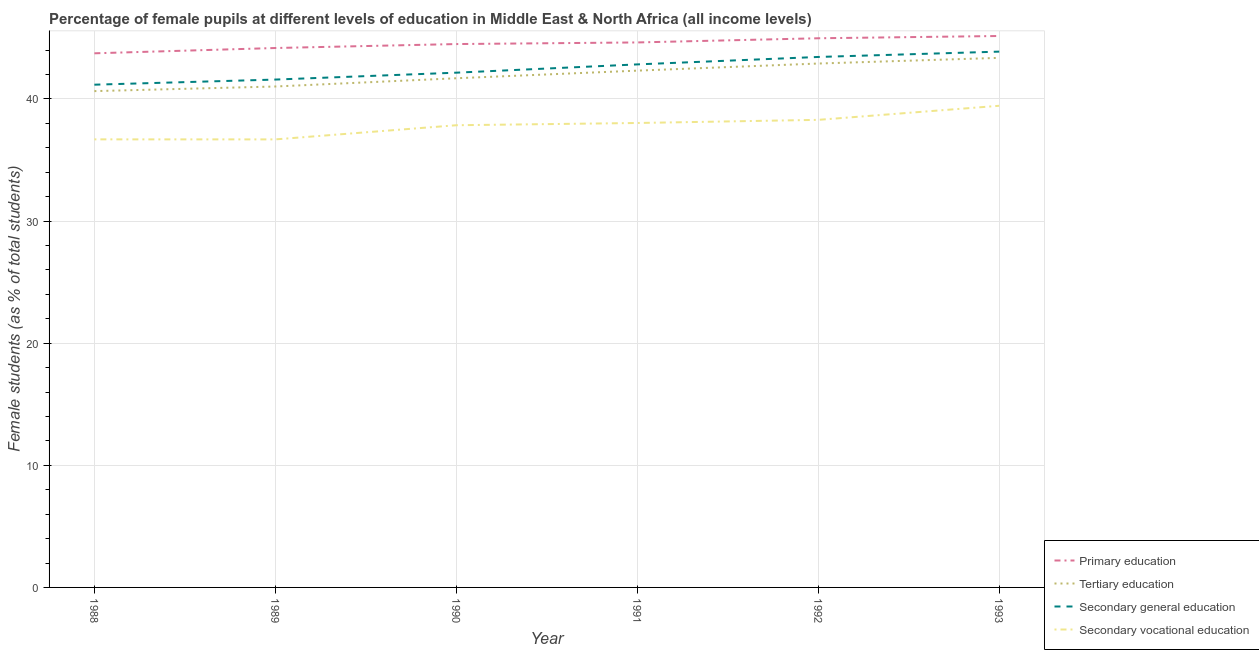What is the percentage of female students in secondary vocational education in 1992?
Offer a very short reply. 38.29. Across all years, what is the maximum percentage of female students in primary education?
Your answer should be compact. 45.16. Across all years, what is the minimum percentage of female students in tertiary education?
Offer a very short reply. 40.65. What is the total percentage of female students in secondary vocational education in the graph?
Keep it short and to the point. 227.01. What is the difference between the percentage of female students in tertiary education in 1992 and that in 1993?
Provide a short and direct response. -0.46. What is the difference between the percentage of female students in secondary education in 1989 and the percentage of female students in tertiary education in 1991?
Your answer should be compact. -0.73. What is the average percentage of female students in primary education per year?
Provide a succinct answer. 44.53. In the year 1988, what is the difference between the percentage of female students in tertiary education and percentage of female students in secondary vocational education?
Make the answer very short. 3.95. What is the ratio of the percentage of female students in primary education in 1991 to that in 1992?
Provide a succinct answer. 0.99. Is the percentage of female students in tertiary education in 1992 less than that in 1993?
Your answer should be very brief. Yes. What is the difference between the highest and the second highest percentage of female students in primary education?
Your answer should be very brief. 0.19. What is the difference between the highest and the lowest percentage of female students in tertiary education?
Offer a terse response. 2.72. In how many years, is the percentage of female students in secondary education greater than the average percentage of female students in secondary education taken over all years?
Your response must be concise. 3. Is the sum of the percentage of female students in secondary vocational education in 1990 and 1992 greater than the maximum percentage of female students in tertiary education across all years?
Provide a succinct answer. Yes. Is it the case that in every year, the sum of the percentage of female students in primary education and percentage of female students in tertiary education is greater than the percentage of female students in secondary education?
Your response must be concise. Yes. How many years are there in the graph?
Your response must be concise. 6. What is the difference between two consecutive major ticks on the Y-axis?
Give a very brief answer. 10. Does the graph contain any zero values?
Your answer should be very brief. No. Does the graph contain grids?
Offer a very short reply. Yes. What is the title of the graph?
Make the answer very short. Percentage of female pupils at different levels of education in Middle East & North Africa (all income levels). What is the label or title of the Y-axis?
Ensure brevity in your answer.  Female students (as % of total students). What is the Female students (as % of total students) in Primary education in 1988?
Provide a short and direct response. 43.74. What is the Female students (as % of total students) in Tertiary education in 1988?
Ensure brevity in your answer.  40.65. What is the Female students (as % of total students) of Secondary general education in 1988?
Your response must be concise. 41.17. What is the Female students (as % of total students) in Secondary vocational education in 1988?
Offer a terse response. 36.69. What is the Female students (as % of total students) in Primary education in 1989?
Offer a very short reply. 44.18. What is the Female students (as % of total students) of Tertiary education in 1989?
Offer a very short reply. 41.02. What is the Female students (as % of total students) in Secondary general education in 1989?
Your response must be concise. 41.59. What is the Female students (as % of total students) in Secondary vocational education in 1989?
Your response must be concise. 36.69. What is the Female students (as % of total students) of Primary education in 1990?
Give a very brief answer. 44.5. What is the Female students (as % of total students) in Tertiary education in 1990?
Keep it short and to the point. 41.7. What is the Female students (as % of total students) in Secondary general education in 1990?
Offer a very short reply. 42.16. What is the Female students (as % of total students) of Secondary vocational education in 1990?
Provide a short and direct response. 37.85. What is the Female students (as % of total students) in Primary education in 1991?
Keep it short and to the point. 44.63. What is the Female students (as % of total students) in Tertiary education in 1991?
Your answer should be very brief. 42.32. What is the Female students (as % of total students) in Secondary general education in 1991?
Your answer should be compact. 42.83. What is the Female students (as % of total students) in Secondary vocational education in 1991?
Make the answer very short. 38.03. What is the Female students (as % of total students) of Primary education in 1992?
Ensure brevity in your answer.  44.97. What is the Female students (as % of total students) of Tertiary education in 1992?
Ensure brevity in your answer.  42.9. What is the Female students (as % of total students) of Secondary general education in 1992?
Make the answer very short. 43.44. What is the Female students (as % of total students) of Secondary vocational education in 1992?
Ensure brevity in your answer.  38.29. What is the Female students (as % of total students) of Primary education in 1993?
Provide a short and direct response. 45.16. What is the Female students (as % of total students) of Tertiary education in 1993?
Ensure brevity in your answer.  43.37. What is the Female students (as % of total students) in Secondary general education in 1993?
Your answer should be very brief. 43.88. What is the Female students (as % of total students) in Secondary vocational education in 1993?
Your response must be concise. 39.45. Across all years, what is the maximum Female students (as % of total students) in Primary education?
Offer a very short reply. 45.16. Across all years, what is the maximum Female students (as % of total students) of Tertiary education?
Provide a short and direct response. 43.37. Across all years, what is the maximum Female students (as % of total students) in Secondary general education?
Ensure brevity in your answer.  43.88. Across all years, what is the maximum Female students (as % of total students) of Secondary vocational education?
Your answer should be very brief. 39.45. Across all years, what is the minimum Female students (as % of total students) in Primary education?
Offer a terse response. 43.74. Across all years, what is the minimum Female students (as % of total students) of Tertiary education?
Make the answer very short. 40.65. Across all years, what is the minimum Female students (as % of total students) of Secondary general education?
Keep it short and to the point. 41.17. Across all years, what is the minimum Female students (as % of total students) of Secondary vocational education?
Your response must be concise. 36.69. What is the total Female students (as % of total students) in Primary education in the graph?
Your answer should be very brief. 267.18. What is the total Female students (as % of total students) in Tertiary education in the graph?
Offer a very short reply. 251.97. What is the total Female students (as % of total students) of Secondary general education in the graph?
Keep it short and to the point. 255.08. What is the total Female students (as % of total students) in Secondary vocational education in the graph?
Your answer should be compact. 227.01. What is the difference between the Female students (as % of total students) of Primary education in 1988 and that in 1989?
Keep it short and to the point. -0.43. What is the difference between the Female students (as % of total students) of Tertiary education in 1988 and that in 1989?
Make the answer very short. -0.38. What is the difference between the Female students (as % of total students) of Secondary general education in 1988 and that in 1989?
Provide a short and direct response. -0.42. What is the difference between the Female students (as % of total students) of Secondary vocational education in 1988 and that in 1989?
Provide a short and direct response. 0. What is the difference between the Female students (as % of total students) of Primary education in 1988 and that in 1990?
Your response must be concise. -0.76. What is the difference between the Female students (as % of total students) of Tertiary education in 1988 and that in 1990?
Make the answer very short. -1.05. What is the difference between the Female students (as % of total students) in Secondary general education in 1988 and that in 1990?
Keep it short and to the point. -0.98. What is the difference between the Female students (as % of total students) in Secondary vocational education in 1988 and that in 1990?
Your response must be concise. -1.16. What is the difference between the Female students (as % of total students) of Primary education in 1988 and that in 1991?
Give a very brief answer. -0.89. What is the difference between the Female students (as % of total students) of Tertiary education in 1988 and that in 1991?
Make the answer very short. -1.68. What is the difference between the Female students (as % of total students) of Secondary general education in 1988 and that in 1991?
Offer a terse response. -1.66. What is the difference between the Female students (as % of total students) of Secondary vocational education in 1988 and that in 1991?
Provide a succinct answer. -1.34. What is the difference between the Female students (as % of total students) of Primary education in 1988 and that in 1992?
Make the answer very short. -1.23. What is the difference between the Female students (as % of total students) of Tertiary education in 1988 and that in 1992?
Offer a terse response. -2.26. What is the difference between the Female students (as % of total students) in Secondary general education in 1988 and that in 1992?
Provide a short and direct response. -2.27. What is the difference between the Female students (as % of total students) in Secondary vocational education in 1988 and that in 1992?
Provide a short and direct response. -1.6. What is the difference between the Female students (as % of total students) in Primary education in 1988 and that in 1993?
Your answer should be compact. -1.42. What is the difference between the Female students (as % of total students) of Tertiary education in 1988 and that in 1993?
Your answer should be very brief. -2.72. What is the difference between the Female students (as % of total students) in Secondary general education in 1988 and that in 1993?
Your answer should be compact. -2.71. What is the difference between the Female students (as % of total students) in Secondary vocational education in 1988 and that in 1993?
Offer a very short reply. -2.75. What is the difference between the Female students (as % of total students) of Primary education in 1989 and that in 1990?
Keep it short and to the point. -0.32. What is the difference between the Female students (as % of total students) in Tertiary education in 1989 and that in 1990?
Make the answer very short. -0.67. What is the difference between the Female students (as % of total students) in Secondary general education in 1989 and that in 1990?
Give a very brief answer. -0.56. What is the difference between the Female students (as % of total students) of Secondary vocational education in 1989 and that in 1990?
Your answer should be compact. -1.16. What is the difference between the Female students (as % of total students) of Primary education in 1989 and that in 1991?
Make the answer very short. -0.46. What is the difference between the Female students (as % of total students) of Tertiary education in 1989 and that in 1991?
Provide a short and direct response. -1.3. What is the difference between the Female students (as % of total students) in Secondary general education in 1989 and that in 1991?
Offer a very short reply. -1.24. What is the difference between the Female students (as % of total students) in Secondary vocational education in 1989 and that in 1991?
Give a very brief answer. -1.34. What is the difference between the Female students (as % of total students) in Primary education in 1989 and that in 1992?
Your response must be concise. -0.8. What is the difference between the Female students (as % of total students) of Tertiary education in 1989 and that in 1992?
Offer a terse response. -1.88. What is the difference between the Female students (as % of total students) in Secondary general education in 1989 and that in 1992?
Ensure brevity in your answer.  -1.85. What is the difference between the Female students (as % of total students) of Secondary vocational education in 1989 and that in 1992?
Make the answer very short. -1.6. What is the difference between the Female students (as % of total students) in Primary education in 1989 and that in 1993?
Offer a terse response. -0.98. What is the difference between the Female students (as % of total students) of Tertiary education in 1989 and that in 1993?
Keep it short and to the point. -2.35. What is the difference between the Female students (as % of total students) in Secondary general education in 1989 and that in 1993?
Your response must be concise. -2.29. What is the difference between the Female students (as % of total students) in Secondary vocational education in 1989 and that in 1993?
Ensure brevity in your answer.  -2.75. What is the difference between the Female students (as % of total students) of Primary education in 1990 and that in 1991?
Keep it short and to the point. -0.13. What is the difference between the Female students (as % of total students) in Tertiary education in 1990 and that in 1991?
Offer a very short reply. -0.62. What is the difference between the Female students (as % of total students) of Secondary general education in 1990 and that in 1991?
Give a very brief answer. -0.68. What is the difference between the Female students (as % of total students) of Secondary vocational education in 1990 and that in 1991?
Offer a very short reply. -0.18. What is the difference between the Female students (as % of total students) of Primary education in 1990 and that in 1992?
Offer a very short reply. -0.47. What is the difference between the Female students (as % of total students) of Tertiary education in 1990 and that in 1992?
Your answer should be very brief. -1.21. What is the difference between the Female students (as % of total students) in Secondary general education in 1990 and that in 1992?
Your response must be concise. -1.29. What is the difference between the Female students (as % of total students) in Secondary vocational education in 1990 and that in 1992?
Your answer should be compact. -0.44. What is the difference between the Female students (as % of total students) in Primary education in 1990 and that in 1993?
Offer a very short reply. -0.66. What is the difference between the Female students (as % of total students) of Tertiary education in 1990 and that in 1993?
Provide a short and direct response. -1.67. What is the difference between the Female students (as % of total students) of Secondary general education in 1990 and that in 1993?
Give a very brief answer. -1.72. What is the difference between the Female students (as % of total students) of Secondary vocational education in 1990 and that in 1993?
Your answer should be very brief. -1.59. What is the difference between the Female students (as % of total students) of Primary education in 1991 and that in 1992?
Your answer should be compact. -0.34. What is the difference between the Female students (as % of total students) in Tertiary education in 1991 and that in 1992?
Provide a succinct answer. -0.58. What is the difference between the Female students (as % of total students) of Secondary general education in 1991 and that in 1992?
Offer a terse response. -0.61. What is the difference between the Female students (as % of total students) of Secondary vocational education in 1991 and that in 1992?
Your answer should be compact. -0.26. What is the difference between the Female students (as % of total students) in Primary education in 1991 and that in 1993?
Your response must be concise. -0.53. What is the difference between the Female students (as % of total students) of Tertiary education in 1991 and that in 1993?
Give a very brief answer. -1.05. What is the difference between the Female students (as % of total students) in Secondary general education in 1991 and that in 1993?
Provide a succinct answer. -1.05. What is the difference between the Female students (as % of total students) of Secondary vocational education in 1991 and that in 1993?
Keep it short and to the point. -1.41. What is the difference between the Female students (as % of total students) in Primary education in 1992 and that in 1993?
Your response must be concise. -0.19. What is the difference between the Female students (as % of total students) of Tertiary education in 1992 and that in 1993?
Your response must be concise. -0.46. What is the difference between the Female students (as % of total students) of Secondary general education in 1992 and that in 1993?
Offer a very short reply. -0.44. What is the difference between the Female students (as % of total students) in Secondary vocational education in 1992 and that in 1993?
Make the answer very short. -1.15. What is the difference between the Female students (as % of total students) of Primary education in 1988 and the Female students (as % of total students) of Tertiary education in 1989?
Offer a terse response. 2.72. What is the difference between the Female students (as % of total students) in Primary education in 1988 and the Female students (as % of total students) in Secondary general education in 1989?
Offer a very short reply. 2.15. What is the difference between the Female students (as % of total students) in Primary education in 1988 and the Female students (as % of total students) in Secondary vocational education in 1989?
Your answer should be very brief. 7.05. What is the difference between the Female students (as % of total students) in Tertiary education in 1988 and the Female students (as % of total students) in Secondary general education in 1989?
Make the answer very short. -0.95. What is the difference between the Female students (as % of total students) in Tertiary education in 1988 and the Female students (as % of total students) in Secondary vocational education in 1989?
Your response must be concise. 3.95. What is the difference between the Female students (as % of total students) of Secondary general education in 1988 and the Female students (as % of total students) of Secondary vocational education in 1989?
Provide a short and direct response. 4.48. What is the difference between the Female students (as % of total students) in Primary education in 1988 and the Female students (as % of total students) in Tertiary education in 1990?
Keep it short and to the point. 2.04. What is the difference between the Female students (as % of total students) in Primary education in 1988 and the Female students (as % of total students) in Secondary general education in 1990?
Provide a short and direct response. 1.59. What is the difference between the Female students (as % of total students) of Primary education in 1988 and the Female students (as % of total students) of Secondary vocational education in 1990?
Provide a succinct answer. 5.89. What is the difference between the Female students (as % of total students) in Tertiary education in 1988 and the Female students (as % of total students) in Secondary general education in 1990?
Make the answer very short. -1.51. What is the difference between the Female students (as % of total students) in Tertiary education in 1988 and the Female students (as % of total students) in Secondary vocational education in 1990?
Make the answer very short. 2.79. What is the difference between the Female students (as % of total students) of Secondary general education in 1988 and the Female students (as % of total students) of Secondary vocational education in 1990?
Your response must be concise. 3.32. What is the difference between the Female students (as % of total students) of Primary education in 1988 and the Female students (as % of total students) of Tertiary education in 1991?
Offer a terse response. 1.42. What is the difference between the Female students (as % of total students) of Primary education in 1988 and the Female students (as % of total students) of Secondary general education in 1991?
Make the answer very short. 0.91. What is the difference between the Female students (as % of total students) in Primary education in 1988 and the Female students (as % of total students) in Secondary vocational education in 1991?
Ensure brevity in your answer.  5.71. What is the difference between the Female students (as % of total students) in Tertiary education in 1988 and the Female students (as % of total students) in Secondary general education in 1991?
Provide a short and direct response. -2.19. What is the difference between the Female students (as % of total students) of Tertiary education in 1988 and the Female students (as % of total students) of Secondary vocational education in 1991?
Your answer should be compact. 2.61. What is the difference between the Female students (as % of total students) of Secondary general education in 1988 and the Female students (as % of total students) of Secondary vocational education in 1991?
Give a very brief answer. 3.14. What is the difference between the Female students (as % of total students) of Primary education in 1988 and the Female students (as % of total students) of Tertiary education in 1992?
Your answer should be very brief. 0.84. What is the difference between the Female students (as % of total students) of Primary education in 1988 and the Female students (as % of total students) of Secondary general education in 1992?
Make the answer very short. 0.3. What is the difference between the Female students (as % of total students) of Primary education in 1988 and the Female students (as % of total students) of Secondary vocational education in 1992?
Your answer should be very brief. 5.45. What is the difference between the Female students (as % of total students) in Tertiary education in 1988 and the Female students (as % of total students) in Secondary general education in 1992?
Your response must be concise. -2.8. What is the difference between the Female students (as % of total students) of Tertiary education in 1988 and the Female students (as % of total students) of Secondary vocational education in 1992?
Your answer should be very brief. 2.35. What is the difference between the Female students (as % of total students) in Secondary general education in 1988 and the Female students (as % of total students) in Secondary vocational education in 1992?
Your response must be concise. 2.88. What is the difference between the Female students (as % of total students) of Primary education in 1988 and the Female students (as % of total students) of Tertiary education in 1993?
Give a very brief answer. 0.37. What is the difference between the Female students (as % of total students) of Primary education in 1988 and the Female students (as % of total students) of Secondary general education in 1993?
Provide a short and direct response. -0.14. What is the difference between the Female students (as % of total students) of Primary education in 1988 and the Female students (as % of total students) of Secondary vocational education in 1993?
Give a very brief answer. 4.3. What is the difference between the Female students (as % of total students) in Tertiary education in 1988 and the Female students (as % of total students) in Secondary general education in 1993?
Your response must be concise. -3.23. What is the difference between the Female students (as % of total students) of Tertiary education in 1988 and the Female students (as % of total students) of Secondary vocational education in 1993?
Offer a terse response. 1.2. What is the difference between the Female students (as % of total students) of Secondary general education in 1988 and the Female students (as % of total students) of Secondary vocational education in 1993?
Ensure brevity in your answer.  1.73. What is the difference between the Female students (as % of total students) in Primary education in 1989 and the Female students (as % of total students) in Tertiary education in 1990?
Your answer should be very brief. 2.48. What is the difference between the Female students (as % of total students) of Primary education in 1989 and the Female students (as % of total students) of Secondary general education in 1990?
Give a very brief answer. 2.02. What is the difference between the Female students (as % of total students) in Primary education in 1989 and the Female students (as % of total students) in Secondary vocational education in 1990?
Ensure brevity in your answer.  6.32. What is the difference between the Female students (as % of total students) in Tertiary education in 1989 and the Female students (as % of total students) in Secondary general education in 1990?
Provide a short and direct response. -1.13. What is the difference between the Female students (as % of total students) of Tertiary education in 1989 and the Female students (as % of total students) of Secondary vocational education in 1990?
Provide a succinct answer. 3.17. What is the difference between the Female students (as % of total students) in Secondary general education in 1989 and the Female students (as % of total students) in Secondary vocational education in 1990?
Your answer should be compact. 3.74. What is the difference between the Female students (as % of total students) of Primary education in 1989 and the Female students (as % of total students) of Tertiary education in 1991?
Provide a short and direct response. 1.85. What is the difference between the Female students (as % of total students) in Primary education in 1989 and the Female students (as % of total students) in Secondary general education in 1991?
Your response must be concise. 1.34. What is the difference between the Female students (as % of total students) in Primary education in 1989 and the Female students (as % of total students) in Secondary vocational education in 1991?
Ensure brevity in your answer.  6.14. What is the difference between the Female students (as % of total students) in Tertiary education in 1989 and the Female students (as % of total students) in Secondary general education in 1991?
Your response must be concise. -1.81. What is the difference between the Female students (as % of total students) of Tertiary education in 1989 and the Female students (as % of total students) of Secondary vocational education in 1991?
Keep it short and to the point. 2.99. What is the difference between the Female students (as % of total students) in Secondary general education in 1989 and the Female students (as % of total students) in Secondary vocational education in 1991?
Offer a terse response. 3.56. What is the difference between the Female students (as % of total students) of Primary education in 1989 and the Female students (as % of total students) of Tertiary education in 1992?
Your answer should be very brief. 1.27. What is the difference between the Female students (as % of total students) in Primary education in 1989 and the Female students (as % of total students) in Secondary general education in 1992?
Give a very brief answer. 0.73. What is the difference between the Female students (as % of total students) in Primary education in 1989 and the Female students (as % of total students) in Secondary vocational education in 1992?
Provide a succinct answer. 5.88. What is the difference between the Female students (as % of total students) of Tertiary education in 1989 and the Female students (as % of total students) of Secondary general education in 1992?
Keep it short and to the point. -2.42. What is the difference between the Female students (as % of total students) of Tertiary education in 1989 and the Female students (as % of total students) of Secondary vocational education in 1992?
Your response must be concise. 2.73. What is the difference between the Female students (as % of total students) of Secondary general education in 1989 and the Female students (as % of total students) of Secondary vocational education in 1992?
Your answer should be compact. 3.3. What is the difference between the Female students (as % of total students) in Primary education in 1989 and the Female students (as % of total students) in Tertiary education in 1993?
Provide a succinct answer. 0.81. What is the difference between the Female students (as % of total students) in Primary education in 1989 and the Female students (as % of total students) in Secondary general education in 1993?
Your answer should be very brief. 0.3. What is the difference between the Female students (as % of total students) in Primary education in 1989 and the Female students (as % of total students) in Secondary vocational education in 1993?
Ensure brevity in your answer.  4.73. What is the difference between the Female students (as % of total students) in Tertiary education in 1989 and the Female students (as % of total students) in Secondary general education in 1993?
Make the answer very short. -2.86. What is the difference between the Female students (as % of total students) of Tertiary education in 1989 and the Female students (as % of total students) of Secondary vocational education in 1993?
Your response must be concise. 1.58. What is the difference between the Female students (as % of total students) in Secondary general education in 1989 and the Female students (as % of total students) in Secondary vocational education in 1993?
Your answer should be very brief. 2.15. What is the difference between the Female students (as % of total students) in Primary education in 1990 and the Female students (as % of total students) in Tertiary education in 1991?
Give a very brief answer. 2.18. What is the difference between the Female students (as % of total students) of Primary education in 1990 and the Female students (as % of total students) of Secondary general education in 1991?
Give a very brief answer. 1.67. What is the difference between the Female students (as % of total students) of Primary education in 1990 and the Female students (as % of total students) of Secondary vocational education in 1991?
Offer a terse response. 6.46. What is the difference between the Female students (as % of total students) in Tertiary education in 1990 and the Female students (as % of total students) in Secondary general education in 1991?
Offer a terse response. -1.13. What is the difference between the Female students (as % of total students) of Tertiary education in 1990 and the Female students (as % of total students) of Secondary vocational education in 1991?
Ensure brevity in your answer.  3.66. What is the difference between the Female students (as % of total students) in Secondary general education in 1990 and the Female students (as % of total students) in Secondary vocational education in 1991?
Your answer should be very brief. 4.12. What is the difference between the Female students (as % of total students) in Primary education in 1990 and the Female students (as % of total students) in Tertiary education in 1992?
Keep it short and to the point. 1.59. What is the difference between the Female students (as % of total students) of Primary education in 1990 and the Female students (as % of total students) of Secondary general education in 1992?
Your response must be concise. 1.06. What is the difference between the Female students (as % of total students) in Primary education in 1990 and the Female students (as % of total students) in Secondary vocational education in 1992?
Provide a short and direct response. 6.21. What is the difference between the Female students (as % of total students) in Tertiary education in 1990 and the Female students (as % of total students) in Secondary general education in 1992?
Offer a very short reply. -1.74. What is the difference between the Female students (as % of total students) of Tertiary education in 1990 and the Female students (as % of total students) of Secondary vocational education in 1992?
Give a very brief answer. 3.41. What is the difference between the Female students (as % of total students) in Secondary general education in 1990 and the Female students (as % of total students) in Secondary vocational education in 1992?
Give a very brief answer. 3.86. What is the difference between the Female students (as % of total students) of Primary education in 1990 and the Female students (as % of total students) of Tertiary education in 1993?
Your answer should be very brief. 1.13. What is the difference between the Female students (as % of total students) in Primary education in 1990 and the Female students (as % of total students) in Secondary general education in 1993?
Keep it short and to the point. 0.62. What is the difference between the Female students (as % of total students) in Primary education in 1990 and the Female students (as % of total students) in Secondary vocational education in 1993?
Offer a terse response. 5.05. What is the difference between the Female students (as % of total students) in Tertiary education in 1990 and the Female students (as % of total students) in Secondary general education in 1993?
Provide a succinct answer. -2.18. What is the difference between the Female students (as % of total students) in Tertiary education in 1990 and the Female students (as % of total students) in Secondary vocational education in 1993?
Provide a succinct answer. 2.25. What is the difference between the Female students (as % of total students) of Secondary general education in 1990 and the Female students (as % of total students) of Secondary vocational education in 1993?
Your answer should be compact. 2.71. What is the difference between the Female students (as % of total students) in Primary education in 1991 and the Female students (as % of total students) in Tertiary education in 1992?
Your answer should be very brief. 1.73. What is the difference between the Female students (as % of total students) of Primary education in 1991 and the Female students (as % of total students) of Secondary general education in 1992?
Keep it short and to the point. 1.19. What is the difference between the Female students (as % of total students) in Primary education in 1991 and the Female students (as % of total students) in Secondary vocational education in 1992?
Your answer should be very brief. 6.34. What is the difference between the Female students (as % of total students) of Tertiary education in 1991 and the Female students (as % of total students) of Secondary general education in 1992?
Provide a succinct answer. -1.12. What is the difference between the Female students (as % of total students) of Tertiary education in 1991 and the Female students (as % of total students) of Secondary vocational education in 1992?
Make the answer very short. 4.03. What is the difference between the Female students (as % of total students) in Secondary general education in 1991 and the Female students (as % of total students) in Secondary vocational education in 1992?
Give a very brief answer. 4.54. What is the difference between the Female students (as % of total students) in Primary education in 1991 and the Female students (as % of total students) in Tertiary education in 1993?
Offer a terse response. 1.26. What is the difference between the Female students (as % of total students) in Primary education in 1991 and the Female students (as % of total students) in Secondary general education in 1993?
Keep it short and to the point. 0.75. What is the difference between the Female students (as % of total students) in Primary education in 1991 and the Female students (as % of total students) in Secondary vocational education in 1993?
Provide a succinct answer. 5.19. What is the difference between the Female students (as % of total students) of Tertiary education in 1991 and the Female students (as % of total students) of Secondary general education in 1993?
Your response must be concise. -1.56. What is the difference between the Female students (as % of total students) of Tertiary education in 1991 and the Female students (as % of total students) of Secondary vocational education in 1993?
Offer a very short reply. 2.88. What is the difference between the Female students (as % of total students) in Secondary general education in 1991 and the Female students (as % of total students) in Secondary vocational education in 1993?
Make the answer very short. 3.39. What is the difference between the Female students (as % of total students) in Primary education in 1992 and the Female students (as % of total students) in Tertiary education in 1993?
Your answer should be very brief. 1.6. What is the difference between the Female students (as % of total students) of Primary education in 1992 and the Female students (as % of total students) of Secondary general education in 1993?
Give a very brief answer. 1.09. What is the difference between the Female students (as % of total students) in Primary education in 1992 and the Female students (as % of total students) in Secondary vocational education in 1993?
Ensure brevity in your answer.  5.53. What is the difference between the Female students (as % of total students) of Tertiary education in 1992 and the Female students (as % of total students) of Secondary general education in 1993?
Your answer should be very brief. -0.98. What is the difference between the Female students (as % of total students) of Tertiary education in 1992 and the Female students (as % of total students) of Secondary vocational education in 1993?
Your answer should be very brief. 3.46. What is the difference between the Female students (as % of total students) in Secondary general education in 1992 and the Female students (as % of total students) in Secondary vocational education in 1993?
Offer a very short reply. 4. What is the average Female students (as % of total students) of Primary education per year?
Make the answer very short. 44.53. What is the average Female students (as % of total students) in Tertiary education per year?
Ensure brevity in your answer.  41.99. What is the average Female students (as % of total students) in Secondary general education per year?
Make the answer very short. 42.51. What is the average Female students (as % of total students) in Secondary vocational education per year?
Keep it short and to the point. 37.84. In the year 1988, what is the difference between the Female students (as % of total students) of Primary education and Female students (as % of total students) of Tertiary education?
Your response must be concise. 3.1. In the year 1988, what is the difference between the Female students (as % of total students) of Primary education and Female students (as % of total students) of Secondary general education?
Your response must be concise. 2.57. In the year 1988, what is the difference between the Female students (as % of total students) in Primary education and Female students (as % of total students) in Secondary vocational education?
Provide a succinct answer. 7.05. In the year 1988, what is the difference between the Female students (as % of total students) of Tertiary education and Female students (as % of total students) of Secondary general education?
Give a very brief answer. -0.53. In the year 1988, what is the difference between the Female students (as % of total students) of Tertiary education and Female students (as % of total students) of Secondary vocational education?
Offer a very short reply. 3.95. In the year 1988, what is the difference between the Female students (as % of total students) of Secondary general education and Female students (as % of total students) of Secondary vocational education?
Ensure brevity in your answer.  4.48. In the year 1989, what is the difference between the Female students (as % of total students) of Primary education and Female students (as % of total students) of Tertiary education?
Offer a very short reply. 3.15. In the year 1989, what is the difference between the Female students (as % of total students) of Primary education and Female students (as % of total students) of Secondary general education?
Give a very brief answer. 2.58. In the year 1989, what is the difference between the Female students (as % of total students) of Primary education and Female students (as % of total students) of Secondary vocational education?
Keep it short and to the point. 7.48. In the year 1989, what is the difference between the Female students (as % of total students) in Tertiary education and Female students (as % of total students) in Secondary general education?
Keep it short and to the point. -0.57. In the year 1989, what is the difference between the Female students (as % of total students) in Tertiary education and Female students (as % of total students) in Secondary vocational education?
Offer a very short reply. 4.33. In the year 1989, what is the difference between the Female students (as % of total students) in Secondary general education and Female students (as % of total students) in Secondary vocational education?
Your answer should be compact. 4.9. In the year 1990, what is the difference between the Female students (as % of total students) of Primary education and Female students (as % of total students) of Tertiary education?
Provide a succinct answer. 2.8. In the year 1990, what is the difference between the Female students (as % of total students) in Primary education and Female students (as % of total students) in Secondary general education?
Your answer should be very brief. 2.34. In the year 1990, what is the difference between the Female students (as % of total students) in Primary education and Female students (as % of total students) in Secondary vocational education?
Provide a short and direct response. 6.65. In the year 1990, what is the difference between the Female students (as % of total students) of Tertiary education and Female students (as % of total students) of Secondary general education?
Offer a terse response. -0.46. In the year 1990, what is the difference between the Female students (as % of total students) in Tertiary education and Female students (as % of total students) in Secondary vocational education?
Make the answer very short. 3.85. In the year 1990, what is the difference between the Female students (as % of total students) in Secondary general education and Female students (as % of total students) in Secondary vocational education?
Offer a terse response. 4.3. In the year 1991, what is the difference between the Female students (as % of total students) in Primary education and Female students (as % of total students) in Tertiary education?
Give a very brief answer. 2.31. In the year 1991, what is the difference between the Female students (as % of total students) of Primary education and Female students (as % of total students) of Secondary general education?
Ensure brevity in your answer.  1.8. In the year 1991, what is the difference between the Female students (as % of total students) in Primary education and Female students (as % of total students) in Secondary vocational education?
Provide a succinct answer. 6.6. In the year 1991, what is the difference between the Female students (as % of total students) of Tertiary education and Female students (as % of total students) of Secondary general education?
Your answer should be compact. -0.51. In the year 1991, what is the difference between the Female students (as % of total students) in Tertiary education and Female students (as % of total students) in Secondary vocational education?
Make the answer very short. 4.29. In the year 1991, what is the difference between the Female students (as % of total students) of Secondary general education and Female students (as % of total students) of Secondary vocational education?
Your answer should be very brief. 4.8. In the year 1992, what is the difference between the Female students (as % of total students) in Primary education and Female students (as % of total students) in Tertiary education?
Your response must be concise. 2.07. In the year 1992, what is the difference between the Female students (as % of total students) in Primary education and Female students (as % of total students) in Secondary general education?
Offer a terse response. 1.53. In the year 1992, what is the difference between the Female students (as % of total students) in Primary education and Female students (as % of total students) in Secondary vocational education?
Make the answer very short. 6.68. In the year 1992, what is the difference between the Female students (as % of total students) in Tertiary education and Female students (as % of total students) in Secondary general education?
Your answer should be compact. -0.54. In the year 1992, what is the difference between the Female students (as % of total students) in Tertiary education and Female students (as % of total students) in Secondary vocational education?
Make the answer very short. 4.61. In the year 1992, what is the difference between the Female students (as % of total students) of Secondary general education and Female students (as % of total students) of Secondary vocational education?
Make the answer very short. 5.15. In the year 1993, what is the difference between the Female students (as % of total students) in Primary education and Female students (as % of total students) in Tertiary education?
Your response must be concise. 1.79. In the year 1993, what is the difference between the Female students (as % of total students) of Primary education and Female students (as % of total students) of Secondary general education?
Provide a short and direct response. 1.28. In the year 1993, what is the difference between the Female students (as % of total students) of Primary education and Female students (as % of total students) of Secondary vocational education?
Offer a very short reply. 5.71. In the year 1993, what is the difference between the Female students (as % of total students) of Tertiary education and Female students (as % of total students) of Secondary general education?
Offer a very short reply. -0.51. In the year 1993, what is the difference between the Female students (as % of total students) in Tertiary education and Female students (as % of total students) in Secondary vocational education?
Keep it short and to the point. 3.92. In the year 1993, what is the difference between the Female students (as % of total students) in Secondary general education and Female students (as % of total students) in Secondary vocational education?
Make the answer very short. 4.43. What is the ratio of the Female students (as % of total students) of Primary education in 1988 to that in 1989?
Offer a terse response. 0.99. What is the ratio of the Female students (as % of total students) in Tertiary education in 1988 to that in 1989?
Provide a succinct answer. 0.99. What is the ratio of the Female students (as % of total students) in Secondary general education in 1988 to that in 1989?
Give a very brief answer. 0.99. What is the ratio of the Female students (as % of total students) in Primary education in 1988 to that in 1990?
Offer a terse response. 0.98. What is the ratio of the Female students (as % of total students) of Tertiary education in 1988 to that in 1990?
Keep it short and to the point. 0.97. What is the ratio of the Female students (as % of total students) in Secondary general education in 1988 to that in 1990?
Offer a terse response. 0.98. What is the ratio of the Female students (as % of total students) of Secondary vocational education in 1988 to that in 1990?
Provide a succinct answer. 0.97. What is the ratio of the Female students (as % of total students) in Primary education in 1988 to that in 1991?
Provide a succinct answer. 0.98. What is the ratio of the Female students (as % of total students) in Tertiary education in 1988 to that in 1991?
Provide a succinct answer. 0.96. What is the ratio of the Female students (as % of total students) in Secondary general education in 1988 to that in 1991?
Give a very brief answer. 0.96. What is the ratio of the Female students (as % of total students) in Secondary vocational education in 1988 to that in 1991?
Your response must be concise. 0.96. What is the ratio of the Female students (as % of total students) of Primary education in 1988 to that in 1992?
Make the answer very short. 0.97. What is the ratio of the Female students (as % of total students) of Tertiary education in 1988 to that in 1992?
Keep it short and to the point. 0.95. What is the ratio of the Female students (as % of total students) of Secondary general education in 1988 to that in 1992?
Ensure brevity in your answer.  0.95. What is the ratio of the Female students (as % of total students) in Primary education in 1988 to that in 1993?
Provide a short and direct response. 0.97. What is the ratio of the Female students (as % of total students) in Tertiary education in 1988 to that in 1993?
Your response must be concise. 0.94. What is the ratio of the Female students (as % of total students) of Secondary general education in 1988 to that in 1993?
Keep it short and to the point. 0.94. What is the ratio of the Female students (as % of total students) of Secondary vocational education in 1988 to that in 1993?
Offer a very short reply. 0.93. What is the ratio of the Female students (as % of total students) of Primary education in 1989 to that in 1990?
Offer a terse response. 0.99. What is the ratio of the Female students (as % of total students) in Tertiary education in 1989 to that in 1990?
Ensure brevity in your answer.  0.98. What is the ratio of the Female students (as % of total students) in Secondary general education in 1989 to that in 1990?
Ensure brevity in your answer.  0.99. What is the ratio of the Female students (as % of total students) in Secondary vocational education in 1989 to that in 1990?
Offer a very short reply. 0.97. What is the ratio of the Female students (as % of total students) of Primary education in 1989 to that in 1991?
Your answer should be very brief. 0.99. What is the ratio of the Female students (as % of total students) of Tertiary education in 1989 to that in 1991?
Ensure brevity in your answer.  0.97. What is the ratio of the Female students (as % of total students) in Secondary general education in 1989 to that in 1991?
Provide a succinct answer. 0.97. What is the ratio of the Female students (as % of total students) in Secondary vocational education in 1989 to that in 1991?
Provide a short and direct response. 0.96. What is the ratio of the Female students (as % of total students) in Primary education in 1989 to that in 1992?
Provide a short and direct response. 0.98. What is the ratio of the Female students (as % of total students) of Tertiary education in 1989 to that in 1992?
Your answer should be compact. 0.96. What is the ratio of the Female students (as % of total students) of Secondary general education in 1989 to that in 1992?
Provide a succinct answer. 0.96. What is the ratio of the Female students (as % of total students) in Secondary vocational education in 1989 to that in 1992?
Offer a very short reply. 0.96. What is the ratio of the Female students (as % of total students) of Primary education in 1989 to that in 1993?
Ensure brevity in your answer.  0.98. What is the ratio of the Female students (as % of total students) of Tertiary education in 1989 to that in 1993?
Make the answer very short. 0.95. What is the ratio of the Female students (as % of total students) of Secondary general education in 1989 to that in 1993?
Ensure brevity in your answer.  0.95. What is the ratio of the Female students (as % of total students) of Secondary vocational education in 1989 to that in 1993?
Offer a very short reply. 0.93. What is the ratio of the Female students (as % of total students) of Primary education in 1990 to that in 1991?
Your answer should be compact. 1. What is the ratio of the Female students (as % of total students) in Secondary general education in 1990 to that in 1991?
Provide a short and direct response. 0.98. What is the ratio of the Female students (as % of total students) of Secondary vocational education in 1990 to that in 1991?
Your answer should be compact. 1. What is the ratio of the Female students (as % of total students) of Tertiary education in 1990 to that in 1992?
Give a very brief answer. 0.97. What is the ratio of the Female students (as % of total students) in Secondary general education in 1990 to that in 1992?
Keep it short and to the point. 0.97. What is the ratio of the Female students (as % of total students) of Primary education in 1990 to that in 1993?
Your response must be concise. 0.99. What is the ratio of the Female students (as % of total students) in Tertiary education in 1990 to that in 1993?
Make the answer very short. 0.96. What is the ratio of the Female students (as % of total students) in Secondary general education in 1990 to that in 1993?
Your answer should be very brief. 0.96. What is the ratio of the Female students (as % of total students) of Secondary vocational education in 1990 to that in 1993?
Provide a short and direct response. 0.96. What is the ratio of the Female students (as % of total students) of Primary education in 1991 to that in 1992?
Keep it short and to the point. 0.99. What is the ratio of the Female students (as % of total students) of Tertiary education in 1991 to that in 1992?
Offer a terse response. 0.99. What is the ratio of the Female students (as % of total students) in Secondary vocational education in 1991 to that in 1992?
Ensure brevity in your answer.  0.99. What is the ratio of the Female students (as % of total students) of Primary education in 1991 to that in 1993?
Your response must be concise. 0.99. What is the ratio of the Female students (as % of total students) of Tertiary education in 1991 to that in 1993?
Your answer should be compact. 0.98. What is the ratio of the Female students (as % of total students) of Secondary general education in 1991 to that in 1993?
Ensure brevity in your answer.  0.98. What is the ratio of the Female students (as % of total students) of Secondary vocational education in 1991 to that in 1993?
Your response must be concise. 0.96. What is the ratio of the Female students (as % of total students) of Tertiary education in 1992 to that in 1993?
Provide a succinct answer. 0.99. What is the ratio of the Female students (as % of total students) in Secondary vocational education in 1992 to that in 1993?
Give a very brief answer. 0.97. What is the difference between the highest and the second highest Female students (as % of total students) of Primary education?
Provide a succinct answer. 0.19. What is the difference between the highest and the second highest Female students (as % of total students) of Tertiary education?
Make the answer very short. 0.46. What is the difference between the highest and the second highest Female students (as % of total students) in Secondary general education?
Keep it short and to the point. 0.44. What is the difference between the highest and the second highest Female students (as % of total students) of Secondary vocational education?
Ensure brevity in your answer.  1.15. What is the difference between the highest and the lowest Female students (as % of total students) of Primary education?
Provide a short and direct response. 1.42. What is the difference between the highest and the lowest Female students (as % of total students) in Tertiary education?
Provide a short and direct response. 2.72. What is the difference between the highest and the lowest Female students (as % of total students) in Secondary general education?
Provide a succinct answer. 2.71. What is the difference between the highest and the lowest Female students (as % of total students) of Secondary vocational education?
Your answer should be compact. 2.75. 